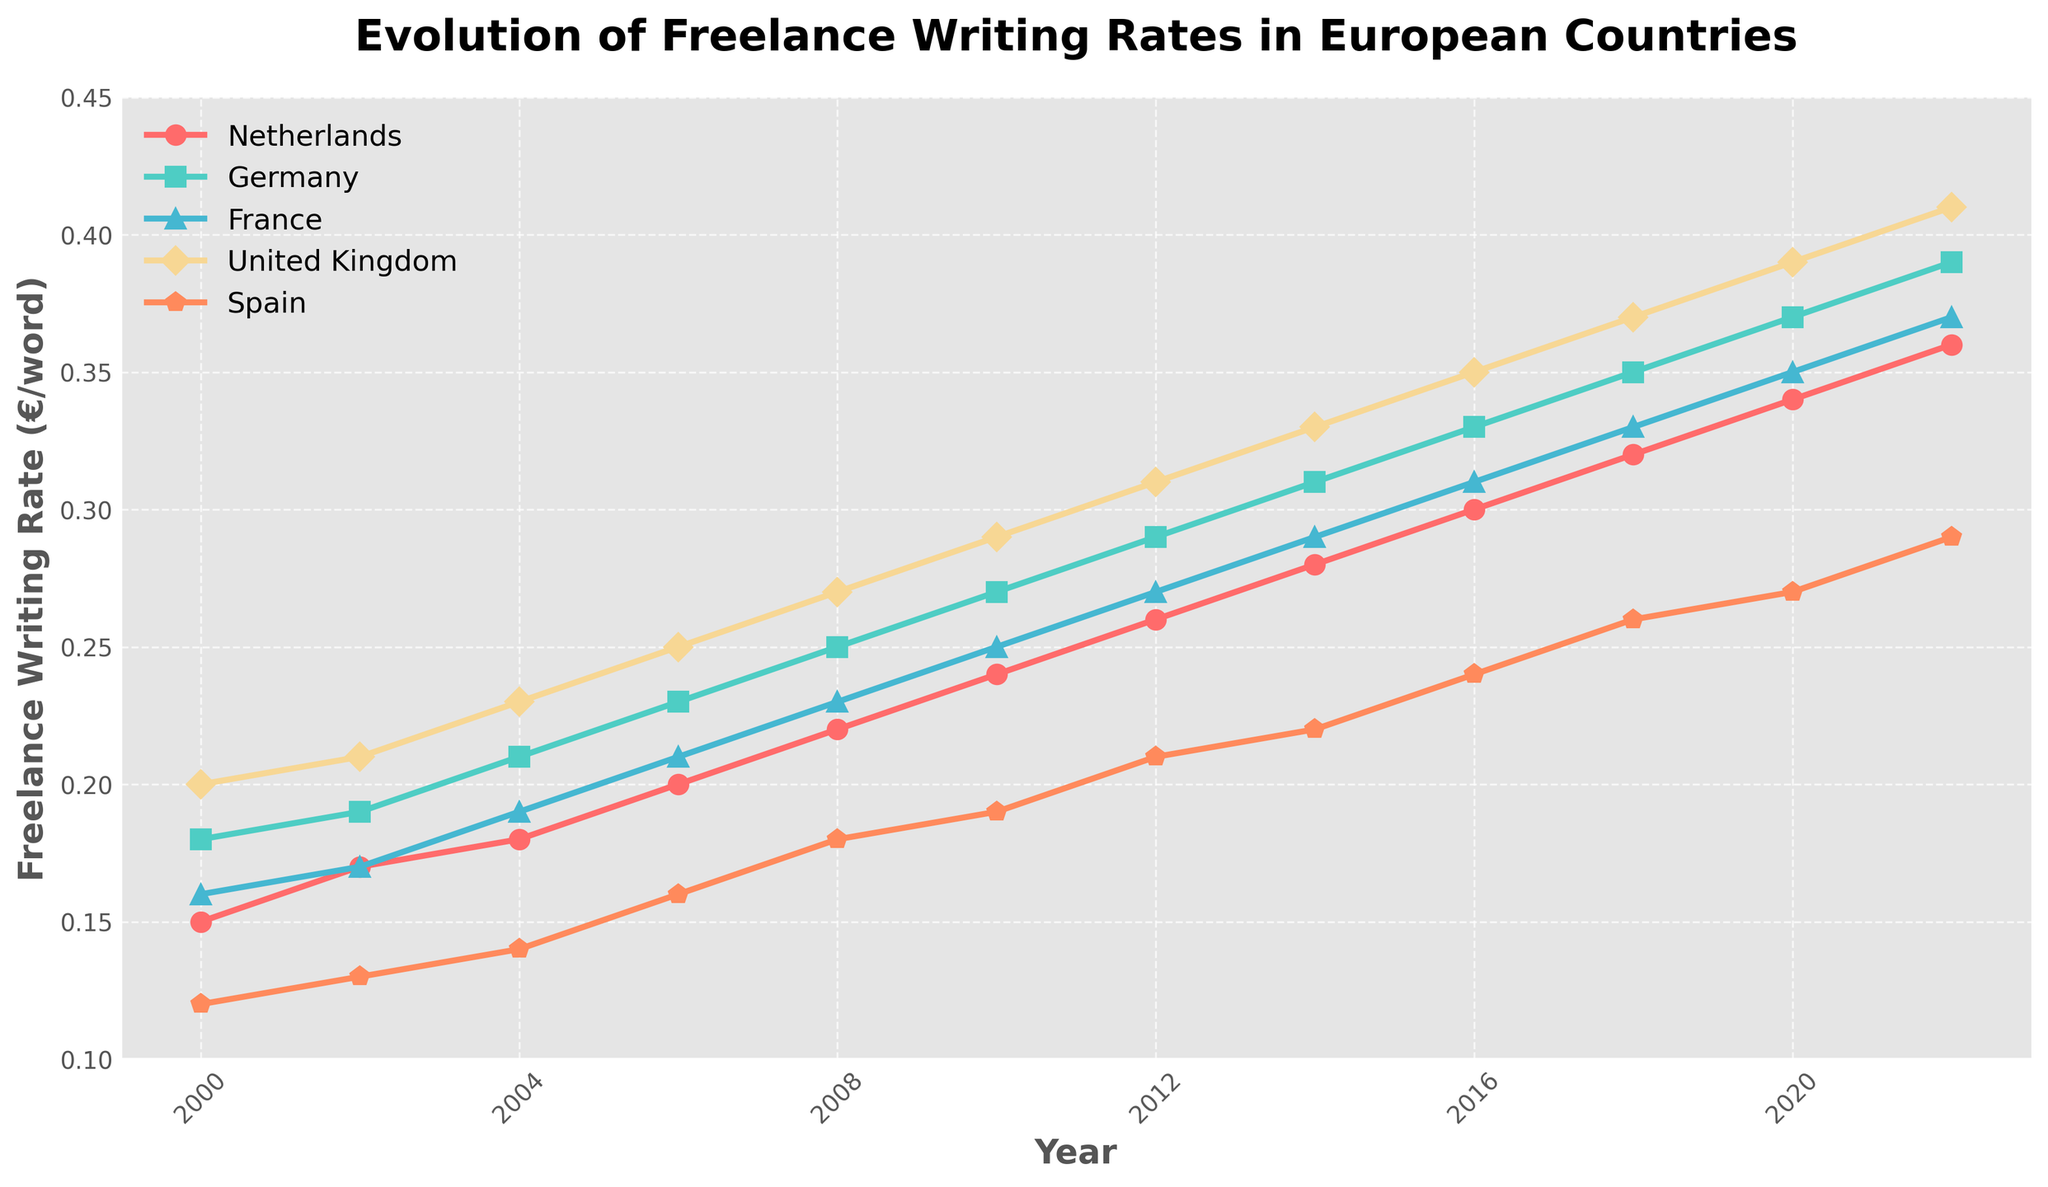What's the trend of freelance writing rates in the Netherlands from 2000 to 2022? The trend can be observed by following the trajectory of the line representing the Netherlands. The rate starts at 0.15 €/word in 2000 and consistently increases every two years, reaching 0.36 €/word in 2022.
Answer: The rates show a consistent upward trend Which country had the highest freelance writing rate in the year 2010? To find the highest rate in 2010, compare the data points for all countries in that year. The United Kingdom had a rate of 0.29 €/word, which is the highest among the given countries.
Answer: United Kingdom Did the freelance writing rate in Spain ever exceed the rate in the Netherlands between 2000 and 2022? By comparing the lines for Spain and the Netherlands over the entire period, we can see that the rate in Spain never exceeds the rate in the Netherlands.
Answer: No How much did the freelance writing rate increase in Germany from 2000 to 2022? To find the increase, subtract the rate in 2000 from the rate in 2022 for Germany. The rates are 0.39 €/word in 2022 and 0.18 €/word in 2000. Therefore, the increase is 0.39 - 0.18 = 0.21 €/word.
Answer: 0.21 €/word In which year did the freelance writing rate in France surpass 0.30 €/word? To determine the year France's rate surpassed 0.30 €/word, examine the France line on the chart. The rate surpasses 0.30 €/word in 2016, reaching 0.31 €/word.
Answer: 2016 What's the difference between the highest and lowest freelance writing rates in 2008 across the given countries? Identify the highest and lowest rates in 2008. The highest is the United Kingdom with 0.27 €/word, and the lowest is Spain with 0.18 €/word. The difference is 0.27 - 0.18 = 0.09 €/word.
Answer: 0.09 €/word Compare the growth rates of the Netherlands and Spain from 2000 to 2010. Which country had a higher growth rate? Calculate the growth for both countries over the decade. Netherlands: 0.24 - 0.15 = 0.09 €/word and Spain: 0.19 - 0.12 = 0.07 €/word. The Netherlands had a higher growth rate.
Answer: Netherlands In which year did the freelance writing rate in the United Kingdom reach 0.37 €/word? Track the line representing the United Kingdom until it hits 0.37 €/word. The rate reaches 0.37 €/word in 2018.
Answer: 2018 What is the average increase per year in the freelance writing rate in Germany from 2000 to 2022? Determine the overall increase in Germany from 2000 (0.18 €/word) to 2022 (0.39 €/word), which is 0.21 €/word. There are 22 years in this period. The average increase per year is 0.21 / 22 ≈ 0.0095 €/word/year.
Answer: 0.0095 €/word/year Which two years have the largest jump in freelance writing rates for the Netherlands? Measure the differences between consecutive data points for the Netherlands. The biggest jumps are between 2016 and 2018 (0.32 - 0.30 = 0.02 €/word) and another between 2014 and 2016 (0.30 - 0.28 = 0.02 €/word), both are equal.
Answer: 2016 to 2018 and 2014 to 2016 